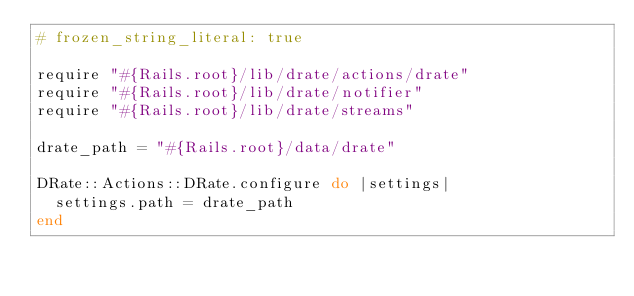<code> <loc_0><loc_0><loc_500><loc_500><_Ruby_># frozen_string_literal: true

require "#{Rails.root}/lib/drate/actions/drate"
require "#{Rails.root}/lib/drate/notifier"
require "#{Rails.root}/lib/drate/streams"

drate_path = "#{Rails.root}/data/drate"

DRate::Actions::DRate.configure do |settings|
  settings.path = drate_path
end
</code> 